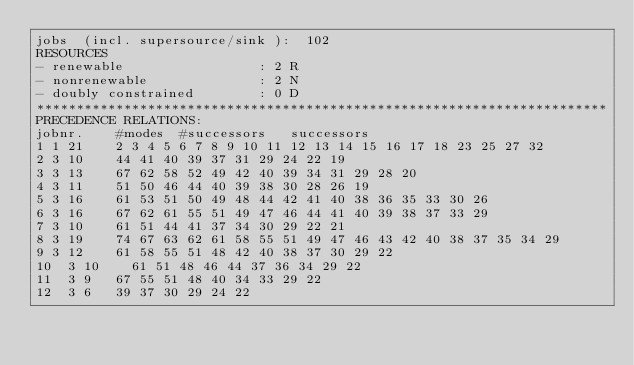<code> <loc_0><loc_0><loc_500><loc_500><_ObjectiveC_>jobs  (incl. supersource/sink ):	102
RESOURCES
- renewable                 : 2 R
- nonrenewable              : 2 N
- doubly constrained        : 0 D
************************************************************************
PRECEDENCE RELATIONS:
jobnr.    #modes  #successors   successors
1	1	21		2 3 4 5 6 7 8 9 10 11 12 13 14 15 16 17 18 23 25 27 32 
2	3	10		44 41 40 39 37 31 29 24 22 19 
3	3	13		67 62 58 52 49 42 40 39 34 31 29 28 20 
4	3	11		51 50 46 44 40 39 38 30 28 26 19 
5	3	16		61 53 51 50 49 48 44 42 41 40 38 36 35 33 30 26 
6	3	16		67 62 61 55 51 49 47 46 44 41 40 39 38 37 33 29 
7	3	10		61 51 44 41 37 34 30 29 22 21 
8	3	19		74 67 63 62 61 58 55 51 49 47 46 43 42 40 38 37 35 34 29 
9	3	12		61 58 55 51 48 42 40 38 37 30 29 22 
10	3	10		61 51 48 46 44 37 36 34 29 22 
11	3	9		67 55 51 48 40 34 33 29 22 
12	3	6		39 37 30 29 24 22 </code> 